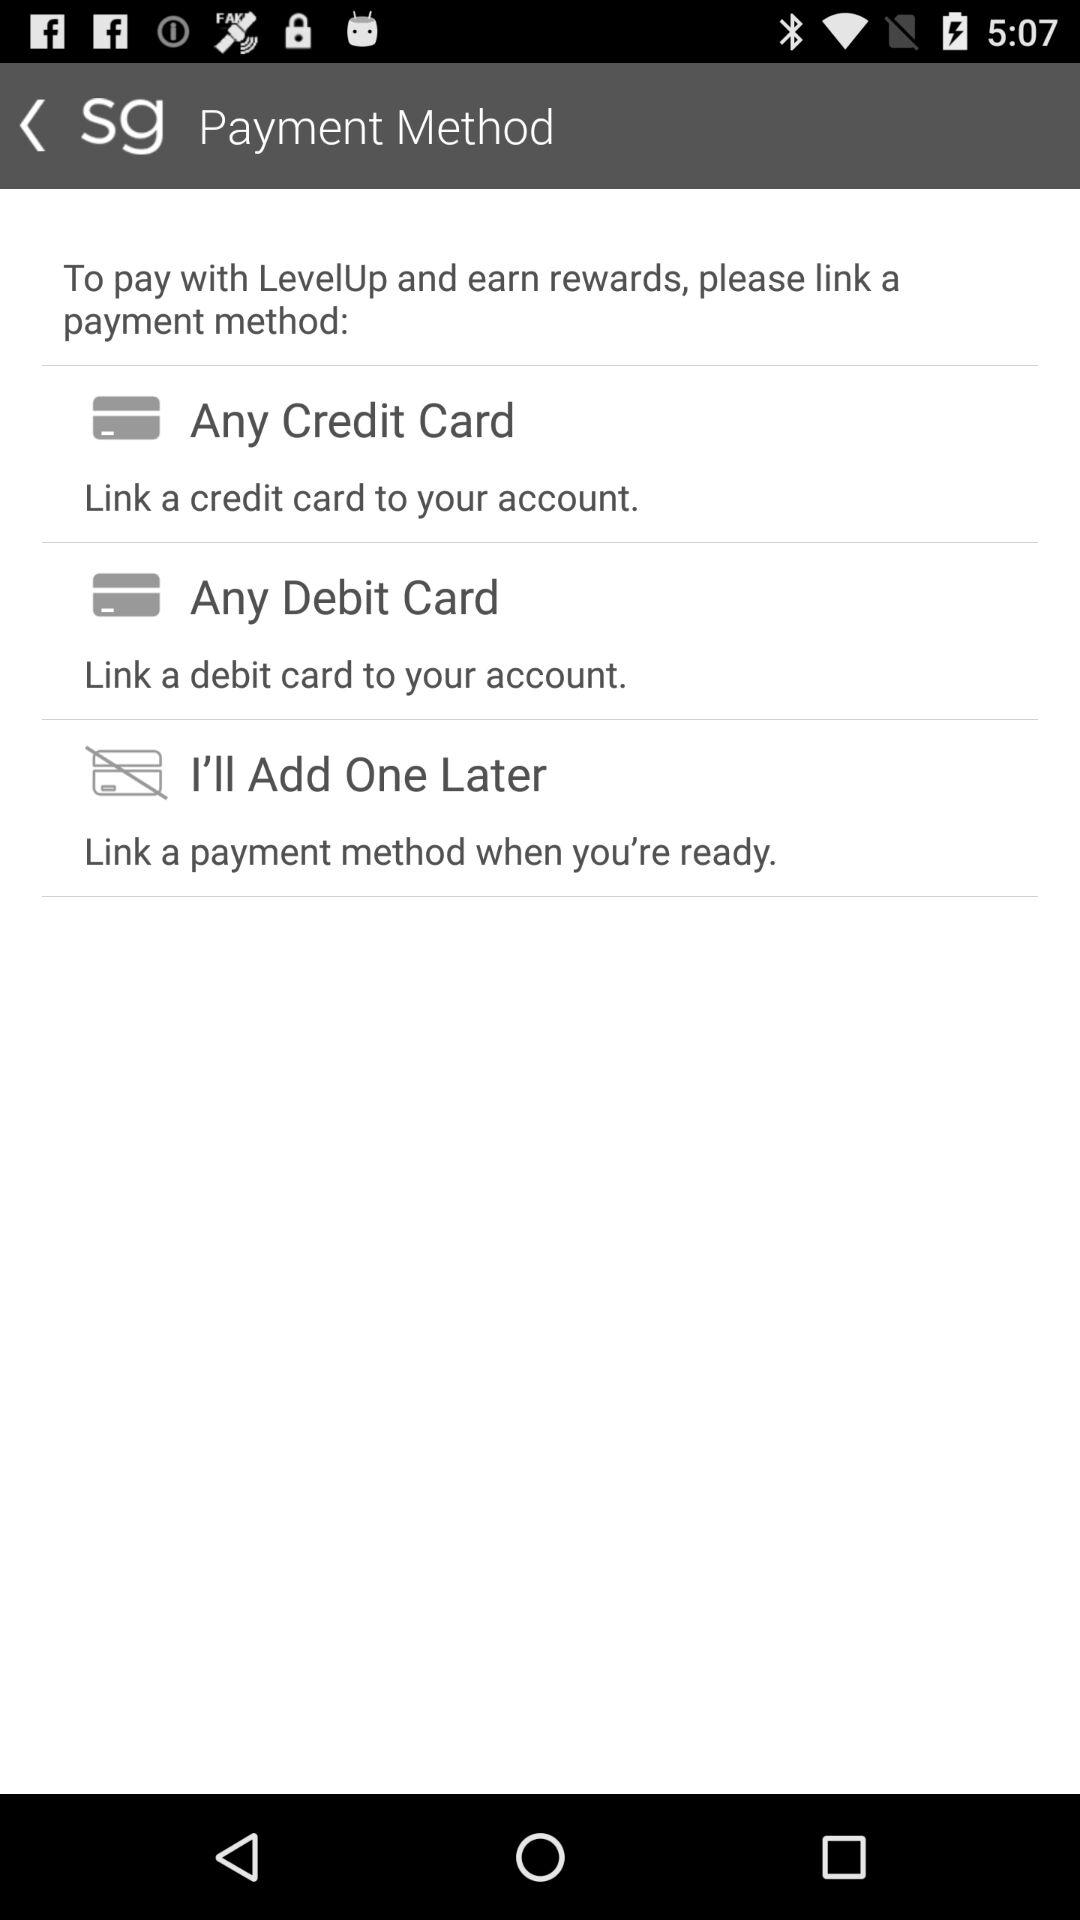How many payment methods are available?
Answer the question using a single word or phrase. 3 